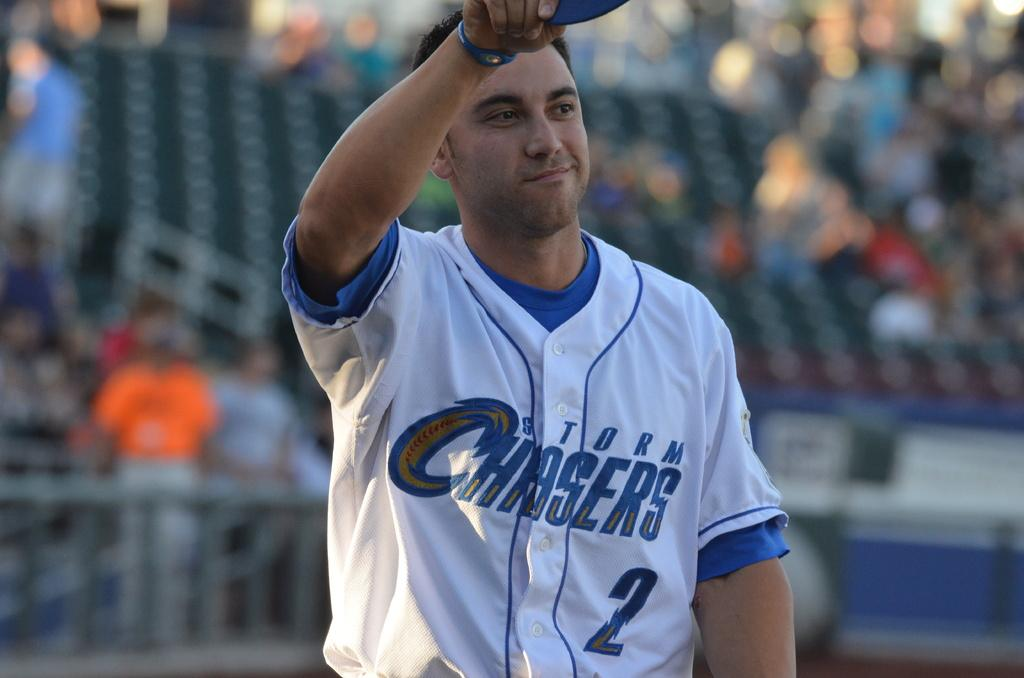<image>
Write a terse but informative summary of the picture. A player wearing white and blue for the Storm Chasers doffs his cap. 